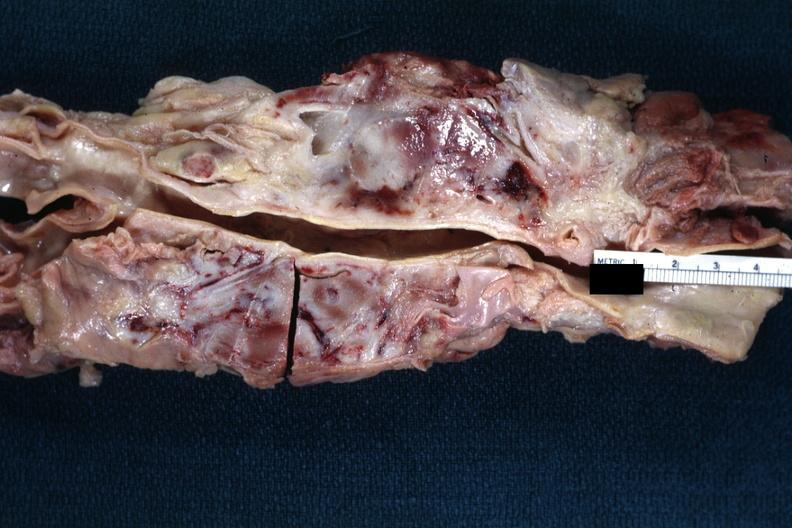what is present?
Answer the question using a single word or phrase. Lymph node 